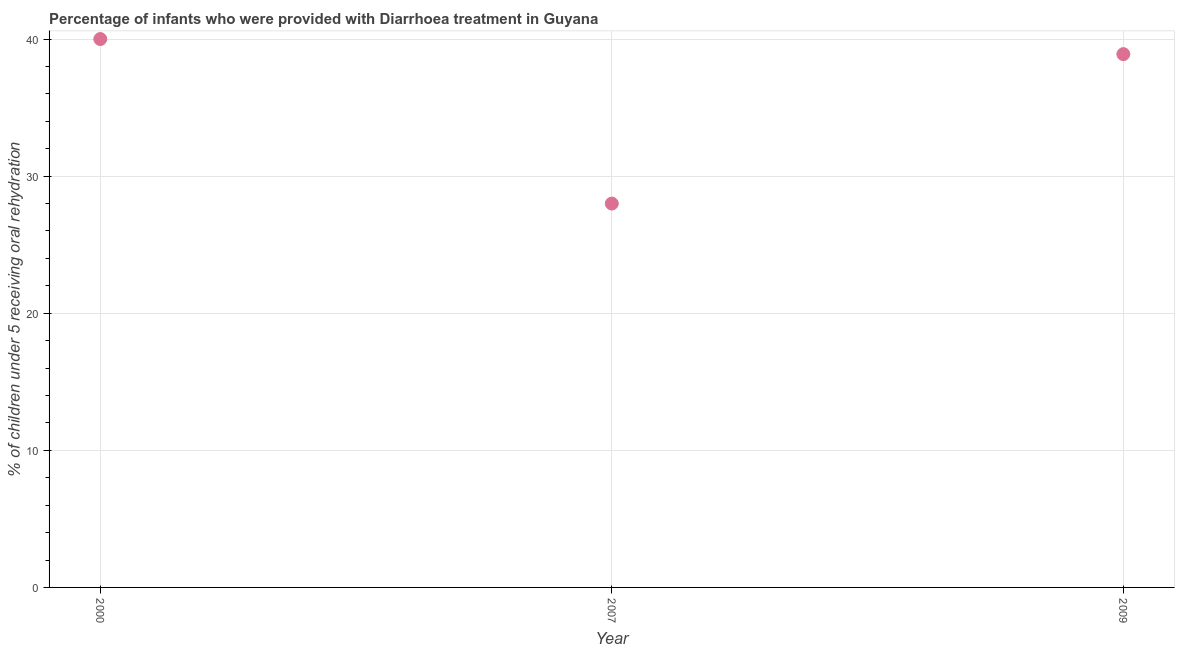Across all years, what is the maximum percentage of children who were provided with treatment diarrhoea?
Make the answer very short. 40. Across all years, what is the minimum percentage of children who were provided with treatment diarrhoea?
Provide a short and direct response. 28. What is the sum of the percentage of children who were provided with treatment diarrhoea?
Keep it short and to the point. 106.9. What is the difference between the percentage of children who were provided with treatment diarrhoea in 2000 and 2009?
Offer a very short reply. 1.1. What is the average percentage of children who were provided with treatment diarrhoea per year?
Your answer should be compact. 35.63. What is the median percentage of children who were provided with treatment diarrhoea?
Keep it short and to the point. 38.9. In how many years, is the percentage of children who were provided with treatment diarrhoea greater than 38 %?
Offer a terse response. 2. What is the ratio of the percentage of children who were provided with treatment diarrhoea in 2000 to that in 2009?
Provide a succinct answer. 1.03. Is the difference between the percentage of children who were provided with treatment diarrhoea in 2000 and 2007 greater than the difference between any two years?
Offer a very short reply. Yes. What is the difference between the highest and the second highest percentage of children who were provided with treatment diarrhoea?
Make the answer very short. 1.1. In how many years, is the percentage of children who were provided with treatment diarrhoea greater than the average percentage of children who were provided with treatment diarrhoea taken over all years?
Your response must be concise. 2. Does the percentage of children who were provided with treatment diarrhoea monotonically increase over the years?
Offer a terse response. No. How many years are there in the graph?
Provide a short and direct response. 3. What is the difference between two consecutive major ticks on the Y-axis?
Offer a very short reply. 10. Does the graph contain any zero values?
Provide a short and direct response. No. Does the graph contain grids?
Your answer should be compact. Yes. What is the title of the graph?
Your response must be concise. Percentage of infants who were provided with Diarrhoea treatment in Guyana. What is the label or title of the X-axis?
Your answer should be very brief. Year. What is the label or title of the Y-axis?
Make the answer very short. % of children under 5 receiving oral rehydration. What is the % of children under 5 receiving oral rehydration in 2007?
Your response must be concise. 28. What is the % of children under 5 receiving oral rehydration in 2009?
Your response must be concise. 38.9. What is the difference between the % of children under 5 receiving oral rehydration in 2000 and 2007?
Your answer should be compact. 12. What is the difference between the % of children under 5 receiving oral rehydration in 2007 and 2009?
Your answer should be very brief. -10.9. What is the ratio of the % of children under 5 receiving oral rehydration in 2000 to that in 2007?
Offer a very short reply. 1.43. What is the ratio of the % of children under 5 receiving oral rehydration in 2000 to that in 2009?
Make the answer very short. 1.03. What is the ratio of the % of children under 5 receiving oral rehydration in 2007 to that in 2009?
Make the answer very short. 0.72. 